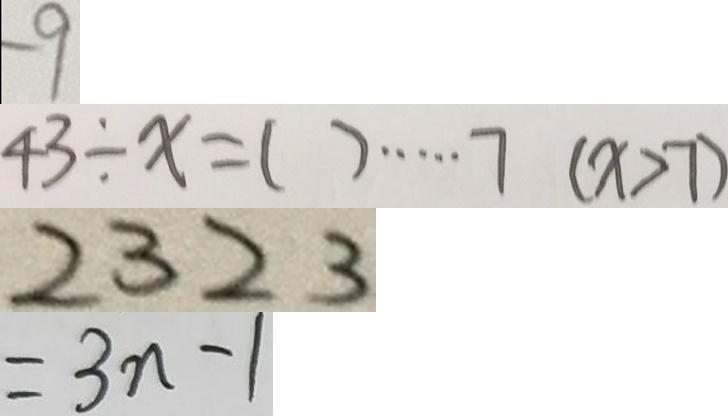<formula> <loc_0><loc_0><loc_500><loc_500>- 9 
 4 3 \div x = ( ) \cdots 7 ( x > 7 ) 
 2 3 2 3 
 = 3 n - 1</formula> 